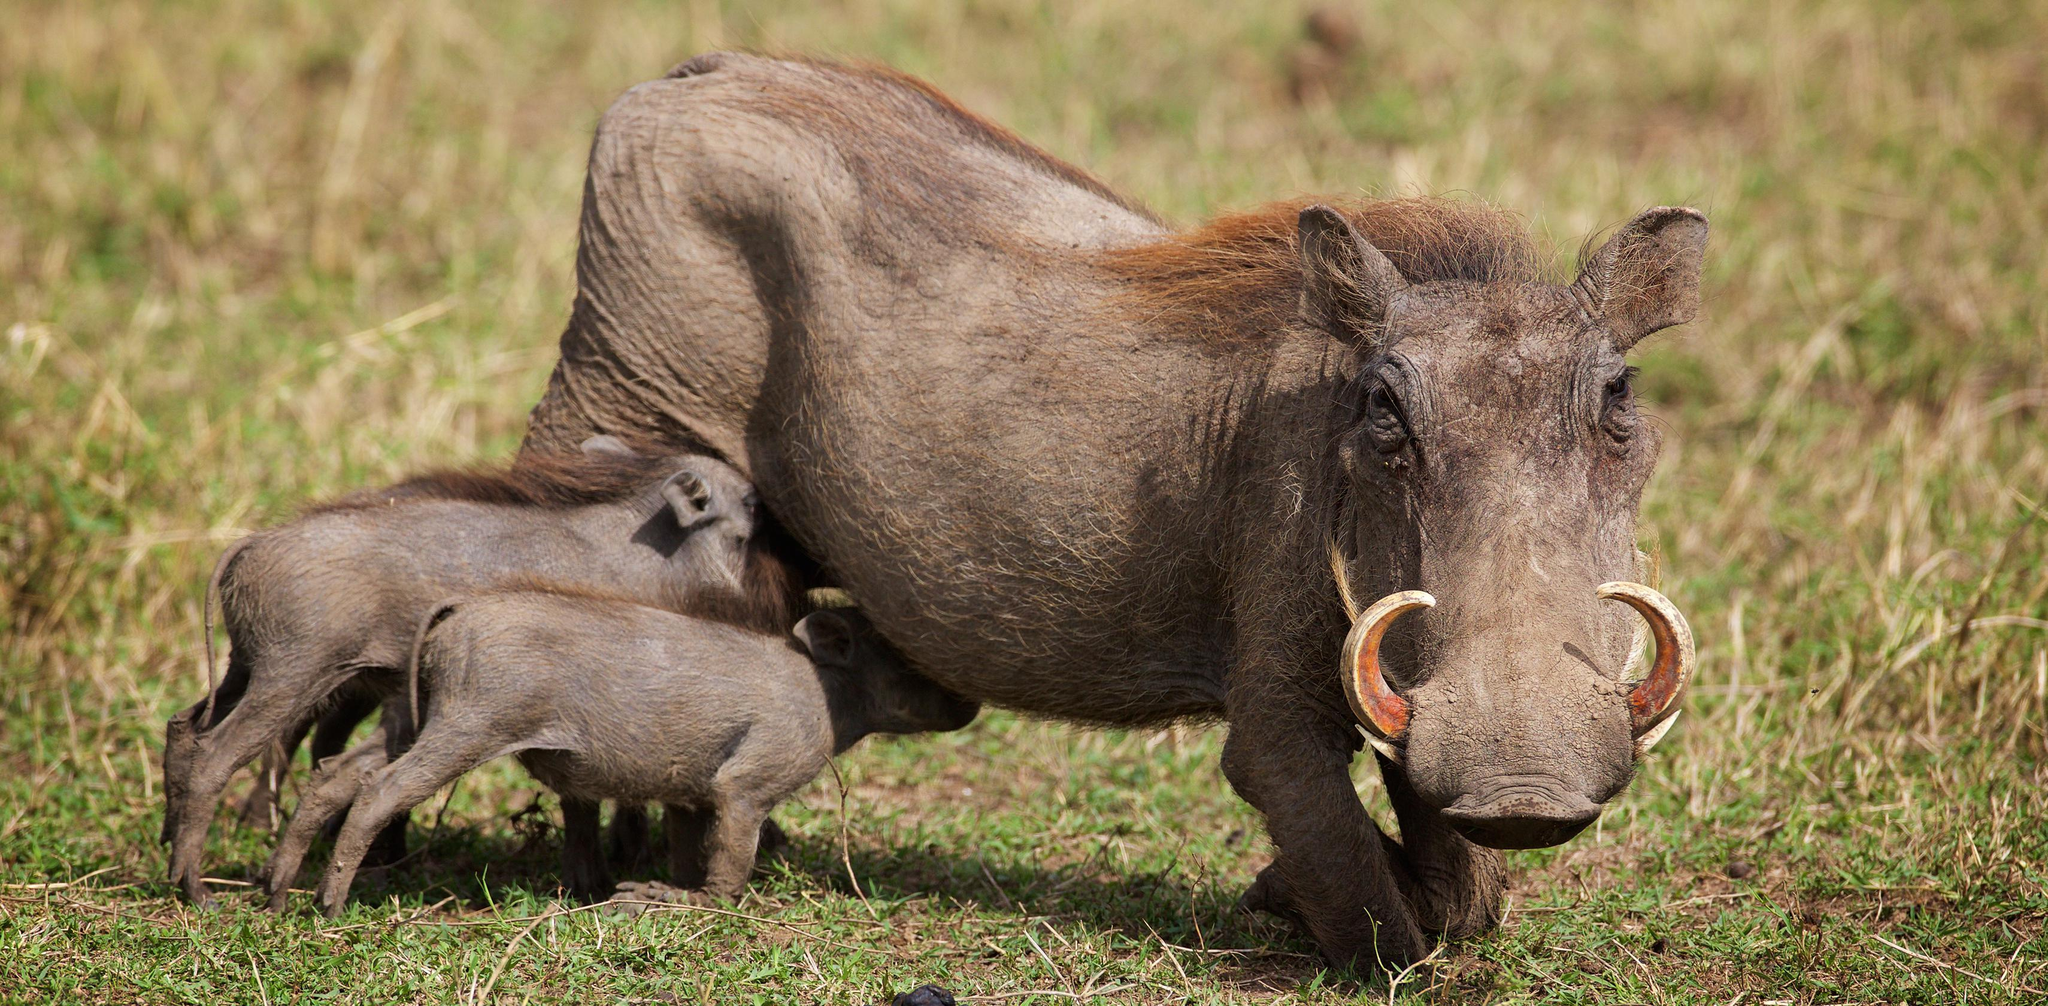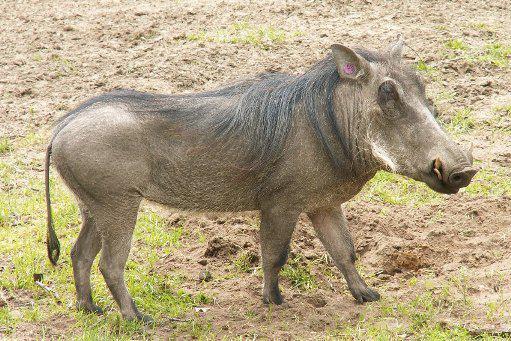The first image is the image on the left, the second image is the image on the right. Examine the images to the left and right. Is the description "There is more than one warthog in one of these images." accurate? Answer yes or no. Yes. 